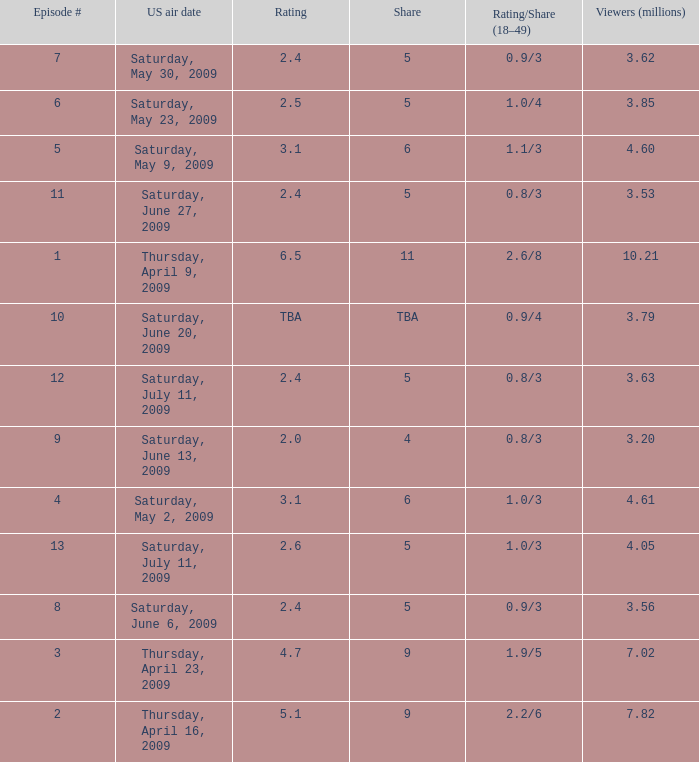What is the rating/share for episode 13? 1.0/3. 